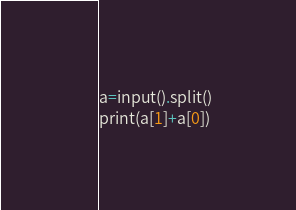<code> <loc_0><loc_0><loc_500><loc_500><_Python_>a=input().split()
print(a[1]+a[0])</code> 